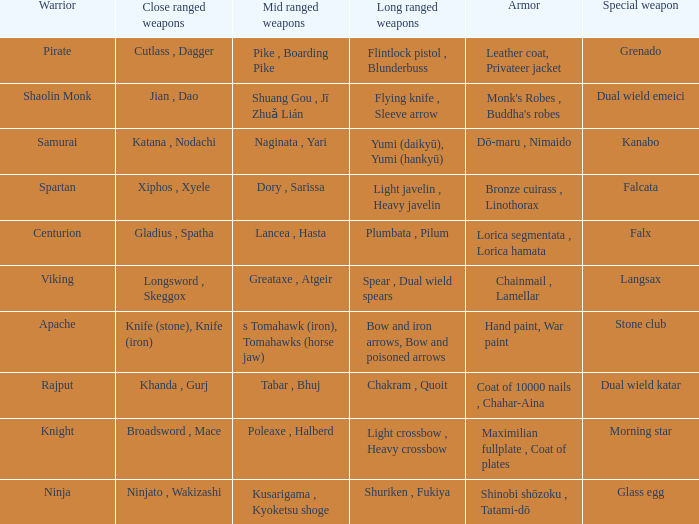If the armor is bronze cuirass , linothorax, what are the close ranged weapons? Xiphos , Xyele. 